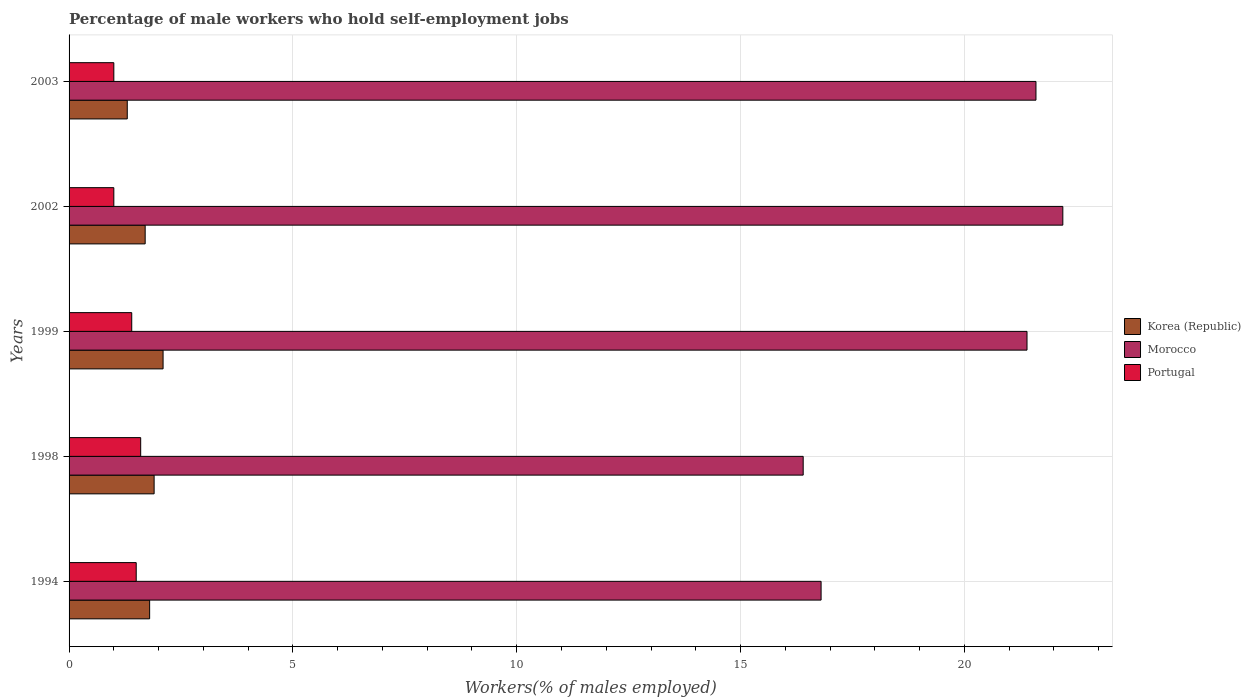How many groups of bars are there?
Keep it short and to the point. 5. What is the label of the 3rd group of bars from the top?
Offer a terse response. 1999. What is the percentage of self-employed male workers in Portugal in 1998?
Offer a terse response. 1.6. Across all years, what is the maximum percentage of self-employed male workers in Portugal?
Give a very brief answer. 1.6. Across all years, what is the minimum percentage of self-employed male workers in Korea (Republic)?
Give a very brief answer. 1.3. What is the total percentage of self-employed male workers in Korea (Republic) in the graph?
Keep it short and to the point. 8.8. What is the difference between the percentage of self-employed male workers in Morocco in 1994 and that in 1999?
Offer a very short reply. -4.6. What is the difference between the percentage of self-employed male workers in Morocco in 2003 and the percentage of self-employed male workers in Portugal in 2002?
Your answer should be compact. 20.6. What is the average percentage of self-employed male workers in Morocco per year?
Keep it short and to the point. 19.68. In the year 2002, what is the difference between the percentage of self-employed male workers in Korea (Republic) and percentage of self-employed male workers in Portugal?
Your answer should be compact. 0.7. In how many years, is the percentage of self-employed male workers in Morocco greater than 11 %?
Keep it short and to the point. 5. What is the ratio of the percentage of self-employed male workers in Portugal in 1998 to that in 2003?
Your response must be concise. 1.6. Is the percentage of self-employed male workers in Korea (Republic) in 1998 less than that in 2002?
Offer a very short reply. No. What is the difference between the highest and the second highest percentage of self-employed male workers in Morocco?
Make the answer very short. 0.6. What is the difference between the highest and the lowest percentage of self-employed male workers in Portugal?
Give a very brief answer. 0.6. In how many years, is the percentage of self-employed male workers in Korea (Republic) greater than the average percentage of self-employed male workers in Korea (Republic) taken over all years?
Your answer should be compact. 3. What does the 2nd bar from the bottom in 2003 represents?
Make the answer very short. Morocco. Is it the case that in every year, the sum of the percentage of self-employed male workers in Korea (Republic) and percentage of self-employed male workers in Morocco is greater than the percentage of self-employed male workers in Portugal?
Your answer should be compact. Yes. How many bars are there?
Provide a succinct answer. 15. What is the difference between two consecutive major ticks on the X-axis?
Keep it short and to the point. 5. Does the graph contain any zero values?
Offer a terse response. No. How are the legend labels stacked?
Provide a short and direct response. Vertical. What is the title of the graph?
Keep it short and to the point. Percentage of male workers who hold self-employment jobs. What is the label or title of the X-axis?
Provide a succinct answer. Workers(% of males employed). What is the Workers(% of males employed) in Korea (Republic) in 1994?
Your response must be concise. 1.8. What is the Workers(% of males employed) in Morocco in 1994?
Keep it short and to the point. 16.8. What is the Workers(% of males employed) of Korea (Republic) in 1998?
Your response must be concise. 1.9. What is the Workers(% of males employed) in Morocco in 1998?
Offer a very short reply. 16.4. What is the Workers(% of males employed) of Portugal in 1998?
Ensure brevity in your answer.  1.6. What is the Workers(% of males employed) in Korea (Republic) in 1999?
Your answer should be compact. 2.1. What is the Workers(% of males employed) of Morocco in 1999?
Make the answer very short. 21.4. What is the Workers(% of males employed) of Portugal in 1999?
Provide a short and direct response. 1.4. What is the Workers(% of males employed) in Korea (Republic) in 2002?
Your answer should be compact. 1.7. What is the Workers(% of males employed) in Morocco in 2002?
Ensure brevity in your answer.  22.2. What is the Workers(% of males employed) in Korea (Republic) in 2003?
Offer a very short reply. 1.3. What is the Workers(% of males employed) of Morocco in 2003?
Give a very brief answer. 21.6. Across all years, what is the maximum Workers(% of males employed) in Korea (Republic)?
Your answer should be very brief. 2.1. Across all years, what is the maximum Workers(% of males employed) in Morocco?
Provide a short and direct response. 22.2. Across all years, what is the maximum Workers(% of males employed) in Portugal?
Offer a very short reply. 1.6. Across all years, what is the minimum Workers(% of males employed) of Korea (Republic)?
Ensure brevity in your answer.  1.3. Across all years, what is the minimum Workers(% of males employed) of Morocco?
Your answer should be compact. 16.4. What is the total Workers(% of males employed) of Morocco in the graph?
Give a very brief answer. 98.4. What is the total Workers(% of males employed) of Portugal in the graph?
Provide a succinct answer. 6.5. What is the difference between the Workers(% of males employed) of Morocco in 1994 and that in 1998?
Your answer should be very brief. 0.4. What is the difference between the Workers(% of males employed) of Portugal in 1994 and that in 1998?
Your answer should be very brief. -0.1. What is the difference between the Workers(% of males employed) of Portugal in 1994 and that in 1999?
Ensure brevity in your answer.  0.1. What is the difference between the Workers(% of males employed) in Korea (Republic) in 1994 and that in 2002?
Give a very brief answer. 0.1. What is the difference between the Workers(% of males employed) of Portugal in 1994 and that in 2002?
Give a very brief answer. 0.5. What is the difference between the Workers(% of males employed) of Portugal in 1998 and that in 1999?
Offer a very short reply. 0.2. What is the difference between the Workers(% of males employed) of Korea (Republic) in 1998 and that in 2002?
Offer a very short reply. 0.2. What is the difference between the Workers(% of males employed) of Morocco in 1998 and that in 2002?
Your response must be concise. -5.8. What is the difference between the Workers(% of males employed) in Portugal in 1998 and that in 2002?
Provide a short and direct response. 0.6. What is the difference between the Workers(% of males employed) of Korea (Republic) in 1998 and that in 2003?
Your response must be concise. 0.6. What is the difference between the Workers(% of males employed) in Morocco in 1998 and that in 2003?
Ensure brevity in your answer.  -5.2. What is the difference between the Workers(% of males employed) in Korea (Republic) in 1999 and that in 2002?
Give a very brief answer. 0.4. What is the difference between the Workers(% of males employed) of Morocco in 1999 and that in 2002?
Your answer should be compact. -0.8. What is the difference between the Workers(% of males employed) in Portugal in 1999 and that in 2002?
Offer a terse response. 0.4. What is the difference between the Workers(% of males employed) of Korea (Republic) in 1999 and that in 2003?
Ensure brevity in your answer.  0.8. What is the difference between the Workers(% of males employed) of Portugal in 2002 and that in 2003?
Ensure brevity in your answer.  0. What is the difference between the Workers(% of males employed) of Korea (Republic) in 1994 and the Workers(% of males employed) of Morocco in 1998?
Offer a terse response. -14.6. What is the difference between the Workers(% of males employed) in Korea (Republic) in 1994 and the Workers(% of males employed) in Portugal in 1998?
Provide a short and direct response. 0.2. What is the difference between the Workers(% of males employed) in Morocco in 1994 and the Workers(% of males employed) in Portugal in 1998?
Give a very brief answer. 15.2. What is the difference between the Workers(% of males employed) of Korea (Republic) in 1994 and the Workers(% of males employed) of Morocco in 1999?
Provide a short and direct response. -19.6. What is the difference between the Workers(% of males employed) in Morocco in 1994 and the Workers(% of males employed) in Portugal in 1999?
Provide a succinct answer. 15.4. What is the difference between the Workers(% of males employed) in Korea (Republic) in 1994 and the Workers(% of males employed) in Morocco in 2002?
Offer a terse response. -20.4. What is the difference between the Workers(% of males employed) in Morocco in 1994 and the Workers(% of males employed) in Portugal in 2002?
Provide a succinct answer. 15.8. What is the difference between the Workers(% of males employed) in Korea (Republic) in 1994 and the Workers(% of males employed) in Morocco in 2003?
Your answer should be compact. -19.8. What is the difference between the Workers(% of males employed) of Morocco in 1994 and the Workers(% of males employed) of Portugal in 2003?
Your answer should be very brief. 15.8. What is the difference between the Workers(% of males employed) in Korea (Republic) in 1998 and the Workers(% of males employed) in Morocco in 1999?
Provide a short and direct response. -19.5. What is the difference between the Workers(% of males employed) of Morocco in 1998 and the Workers(% of males employed) of Portugal in 1999?
Provide a succinct answer. 15. What is the difference between the Workers(% of males employed) of Korea (Republic) in 1998 and the Workers(% of males employed) of Morocco in 2002?
Your answer should be very brief. -20.3. What is the difference between the Workers(% of males employed) in Korea (Republic) in 1998 and the Workers(% of males employed) in Portugal in 2002?
Offer a very short reply. 0.9. What is the difference between the Workers(% of males employed) of Korea (Republic) in 1998 and the Workers(% of males employed) of Morocco in 2003?
Make the answer very short. -19.7. What is the difference between the Workers(% of males employed) of Korea (Republic) in 1998 and the Workers(% of males employed) of Portugal in 2003?
Give a very brief answer. 0.9. What is the difference between the Workers(% of males employed) of Morocco in 1998 and the Workers(% of males employed) of Portugal in 2003?
Offer a terse response. 15.4. What is the difference between the Workers(% of males employed) in Korea (Republic) in 1999 and the Workers(% of males employed) in Morocco in 2002?
Provide a succinct answer. -20.1. What is the difference between the Workers(% of males employed) in Morocco in 1999 and the Workers(% of males employed) in Portugal in 2002?
Provide a short and direct response. 20.4. What is the difference between the Workers(% of males employed) in Korea (Republic) in 1999 and the Workers(% of males employed) in Morocco in 2003?
Make the answer very short. -19.5. What is the difference between the Workers(% of males employed) of Morocco in 1999 and the Workers(% of males employed) of Portugal in 2003?
Provide a short and direct response. 20.4. What is the difference between the Workers(% of males employed) of Korea (Republic) in 2002 and the Workers(% of males employed) of Morocco in 2003?
Provide a succinct answer. -19.9. What is the difference between the Workers(% of males employed) of Morocco in 2002 and the Workers(% of males employed) of Portugal in 2003?
Offer a terse response. 21.2. What is the average Workers(% of males employed) in Korea (Republic) per year?
Your answer should be very brief. 1.76. What is the average Workers(% of males employed) in Morocco per year?
Make the answer very short. 19.68. What is the average Workers(% of males employed) in Portugal per year?
Keep it short and to the point. 1.3. In the year 1994, what is the difference between the Workers(% of males employed) of Korea (Republic) and Workers(% of males employed) of Portugal?
Make the answer very short. 0.3. In the year 1998, what is the difference between the Workers(% of males employed) of Korea (Republic) and Workers(% of males employed) of Morocco?
Give a very brief answer. -14.5. In the year 1998, what is the difference between the Workers(% of males employed) of Morocco and Workers(% of males employed) of Portugal?
Your response must be concise. 14.8. In the year 1999, what is the difference between the Workers(% of males employed) in Korea (Republic) and Workers(% of males employed) in Morocco?
Your response must be concise. -19.3. In the year 1999, what is the difference between the Workers(% of males employed) of Korea (Republic) and Workers(% of males employed) of Portugal?
Your answer should be compact. 0.7. In the year 2002, what is the difference between the Workers(% of males employed) of Korea (Republic) and Workers(% of males employed) of Morocco?
Your response must be concise. -20.5. In the year 2002, what is the difference between the Workers(% of males employed) of Korea (Republic) and Workers(% of males employed) of Portugal?
Offer a terse response. 0.7. In the year 2002, what is the difference between the Workers(% of males employed) in Morocco and Workers(% of males employed) in Portugal?
Ensure brevity in your answer.  21.2. In the year 2003, what is the difference between the Workers(% of males employed) in Korea (Republic) and Workers(% of males employed) in Morocco?
Give a very brief answer. -20.3. In the year 2003, what is the difference between the Workers(% of males employed) of Morocco and Workers(% of males employed) of Portugal?
Your answer should be very brief. 20.6. What is the ratio of the Workers(% of males employed) in Morocco in 1994 to that in 1998?
Provide a short and direct response. 1.02. What is the ratio of the Workers(% of males employed) in Morocco in 1994 to that in 1999?
Ensure brevity in your answer.  0.79. What is the ratio of the Workers(% of males employed) of Portugal in 1994 to that in 1999?
Keep it short and to the point. 1.07. What is the ratio of the Workers(% of males employed) of Korea (Republic) in 1994 to that in 2002?
Your answer should be very brief. 1.06. What is the ratio of the Workers(% of males employed) in Morocco in 1994 to that in 2002?
Your answer should be very brief. 0.76. What is the ratio of the Workers(% of males employed) in Portugal in 1994 to that in 2002?
Your response must be concise. 1.5. What is the ratio of the Workers(% of males employed) of Korea (Republic) in 1994 to that in 2003?
Make the answer very short. 1.38. What is the ratio of the Workers(% of males employed) in Morocco in 1994 to that in 2003?
Offer a terse response. 0.78. What is the ratio of the Workers(% of males employed) of Portugal in 1994 to that in 2003?
Your answer should be very brief. 1.5. What is the ratio of the Workers(% of males employed) of Korea (Republic) in 1998 to that in 1999?
Offer a terse response. 0.9. What is the ratio of the Workers(% of males employed) of Morocco in 1998 to that in 1999?
Provide a succinct answer. 0.77. What is the ratio of the Workers(% of males employed) of Korea (Republic) in 1998 to that in 2002?
Offer a very short reply. 1.12. What is the ratio of the Workers(% of males employed) of Morocco in 1998 to that in 2002?
Provide a succinct answer. 0.74. What is the ratio of the Workers(% of males employed) in Portugal in 1998 to that in 2002?
Your answer should be very brief. 1.6. What is the ratio of the Workers(% of males employed) of Korea (Republic) in 1998 to that in 2003?
Give a very brief answer. 1.46. What is the ratio of the Workers(% of males employed) of Morocco in 1998 to that in 2003?
Your response must be concise. 0.76. What is the ratio of the Workers(% of males employed) in Korea (Republic) in 1999 to that in 2002?
Provide a short and direct response. 1.24. What is the ratio of the Workers(% of males employed) in Portugal in 1999 to that in 2002?
Your response must be concise. 1.4. What is the ratio of the Workers(% of males employed) in Korea (Republic) in 1999 to that in 2003?
Your response must be concise. 1.62. What is the ratio of the Workers(% of males employed) in Korea (Republic) in 2002 to that in 2003?
Make the answer very short. 1.31. What is the ratio of the Workers(% of males employed) of Morocco in 2002 to that in 2003?
Keep it short and to the point. 1.03. What is the ratio of the Workers(% of males employed) of Portugal in 2002 to that in 2003?
Make the answer very short. 1. What is the difference between the highest and the second highest Workers(% of males employed) in Korea (Republic)?
Ensure brevity in your answer.  0.2. What is the difference between the highest and the lowest Workers(% of males employed) of Korea (Republic)?
Keep it short and to the point. 0.8. What is the difference between the highest and the lowest Workers(% of males employed) in Morocco?
Give a very brief answer. 5.8. What is the difference between the highest and the lowest Workers(% of males employed) of Portugal?
Your response must be concise. 0.6. 